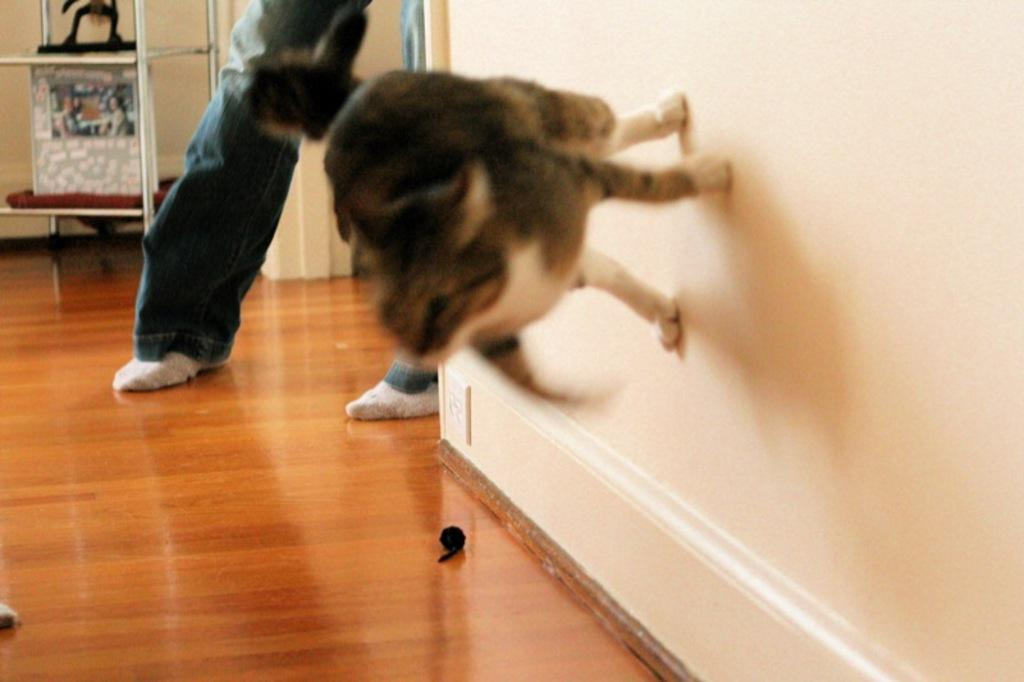What type of animal is present in the image? There is an animal in the image, but the specific type cannot be determined from the provided facts. Can you describe any human presence in the image? A person's leg is visible in the image. What type of voyage is the kitten embarking on in the image? There is no kitten present in the image, so it cannot be determined if a kitten is embarking on a voyage. 